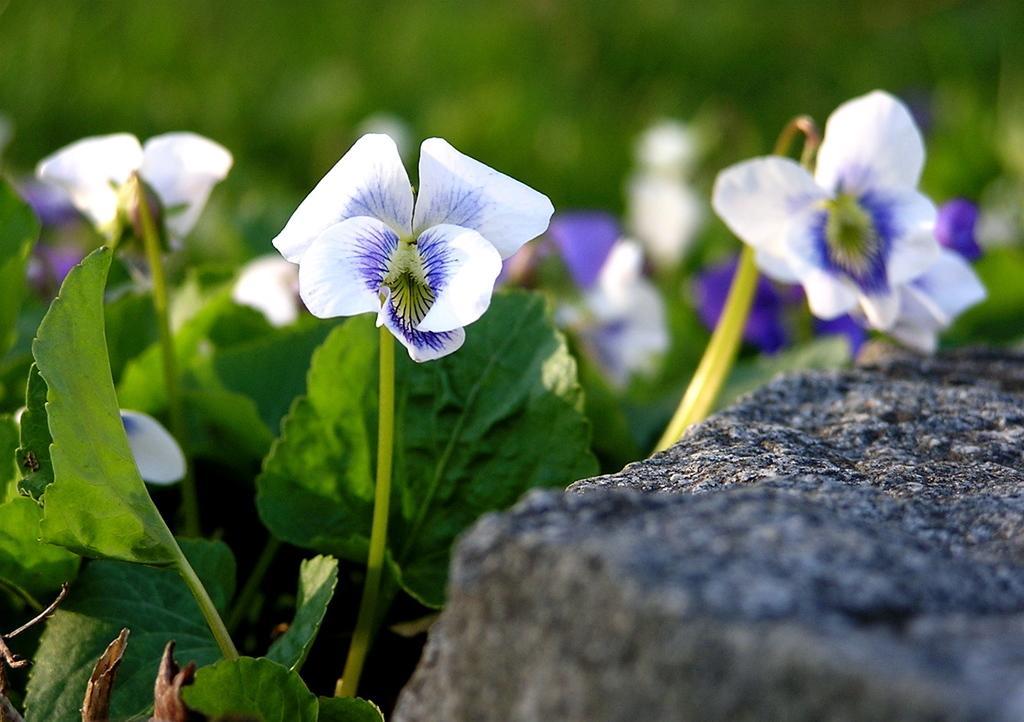Please provide a concise description of this image. In the image there are white and purple flowers to a plant in front of a rock. 